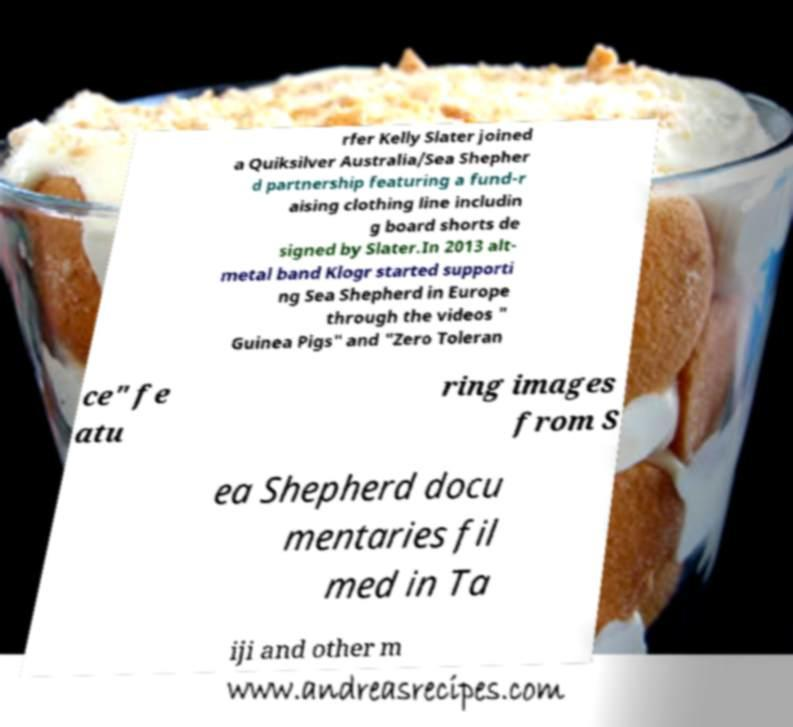There's text embedded in this image that I need extracted. Can you transcribe it verbatim? rfer Kelly Slater joined a Quiksilver Australia/Sea Shepher d partnership featuring a fund-r aising clothing line includin g board shorts de signed by Slater.In 2013 alt- metal band Klogr started supporti ng Sea Shepherd in Europe through the videos " Guinea Pigs" and "Zero Toleran ce" fe atu ring images from S ea Shepherd docu mentaries fil med in Ta iji and other m 